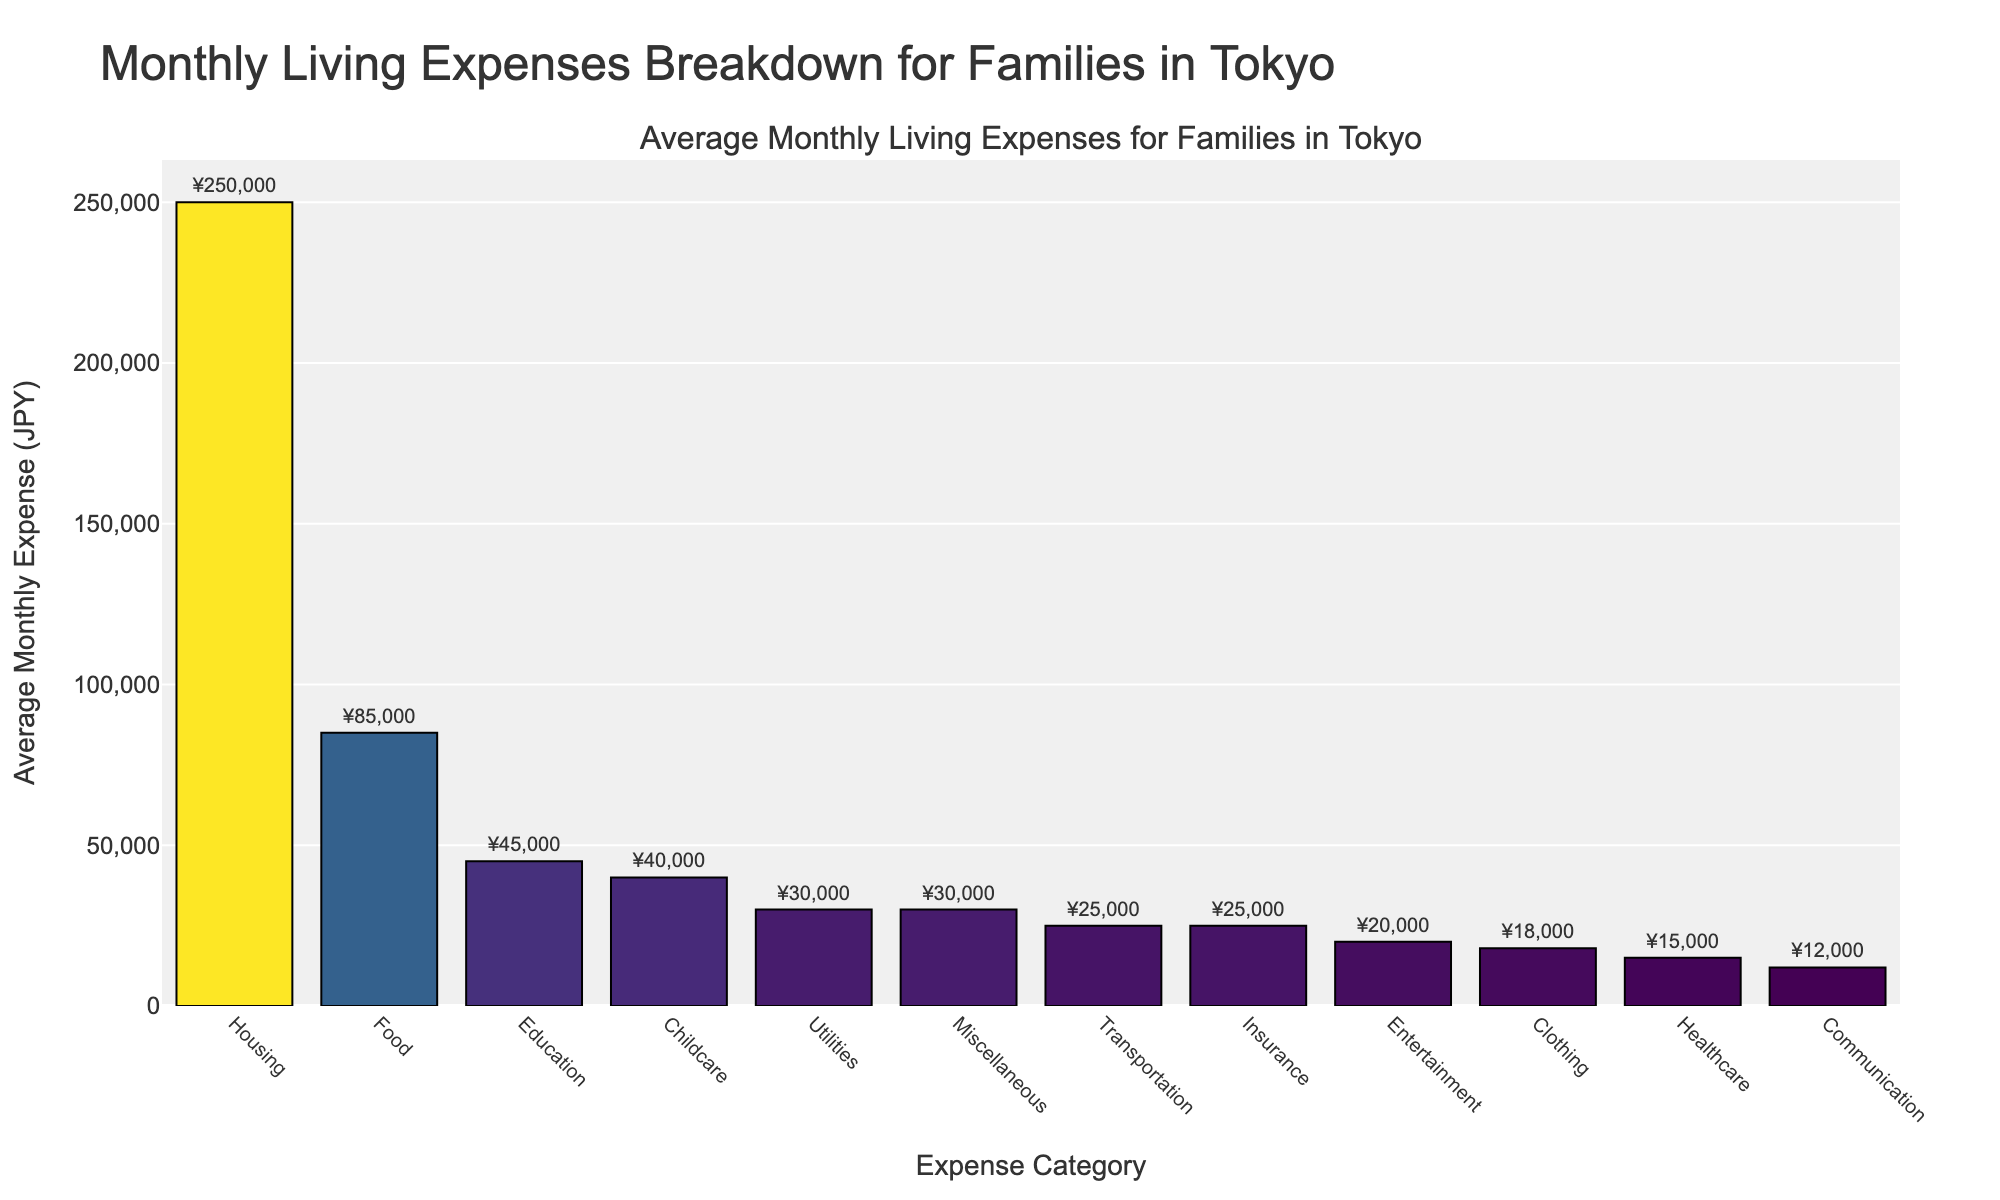Which category has the highest average monthly expense? Looking at the bar chart, the category with the tallest bar represents the highest average monthly expense.
Answer: Housing Which two categories have the lowest average monthly expenses, and what are their values? By comparing the heights of the bars, the two shortest bars represent the lowest expenses. These are Communication (¥12,000) and Healthcare (¥15,000).
Answer: Communication and Healthcare, ¥12,000 and ¥15,000 How much more expensive is Housing compared to Food? Subtract the expense for Food from the expense for Housing: ¥250,000 - ¥85,000 = ¥165,000.
Answer: ¥165,000 What is the combined average monthly expense for Utilities, Healthcare, and Education? Sum the expenses: ¥30,000 (Utilities) + ¥15,000 (Healthcare) + ¥45,000 (Education) = ¥90,000.
Answer: ¥90,000 Which category has an average monthly expense closest to ¥25,000? Identifying the bars around ¥25,000 and checking their labels, we find Transportation and Insurance both at ¥25,000.
Answer: Transportation and Insurance Is the average monthly expense for Entertainment higher or lower than Clothing? By comparing the heights of the bars, Entertainment (¥20,000) is taller than Clothing (¥18,000).
Answer: Higher What is the range of average monthly expenses? The range is calculated by subtracting the smallest expense from the largest. Range = ¥250,000 (Housing) - ¥12,000 (Communication) = ¥238,000.
Answer: ¥238,000 What's the median value of the average monthly expenses? To find the median, first sort the expenses and then locate the middle value. The sorted expenses are: ¥12,000, ¥15,000, ¥18,000, ¥20,000, ¥25,000, ¥25,000, ¥30,000, ¥30,000, ¥40,000, ¥45,000, ¥85,000, ¥250,000. With 12 data points, the median is the average of the 6th and 7th values: (¥25,000 + ¥30,000) / 2 = ¥27,500.
Answer: ¥27,500 